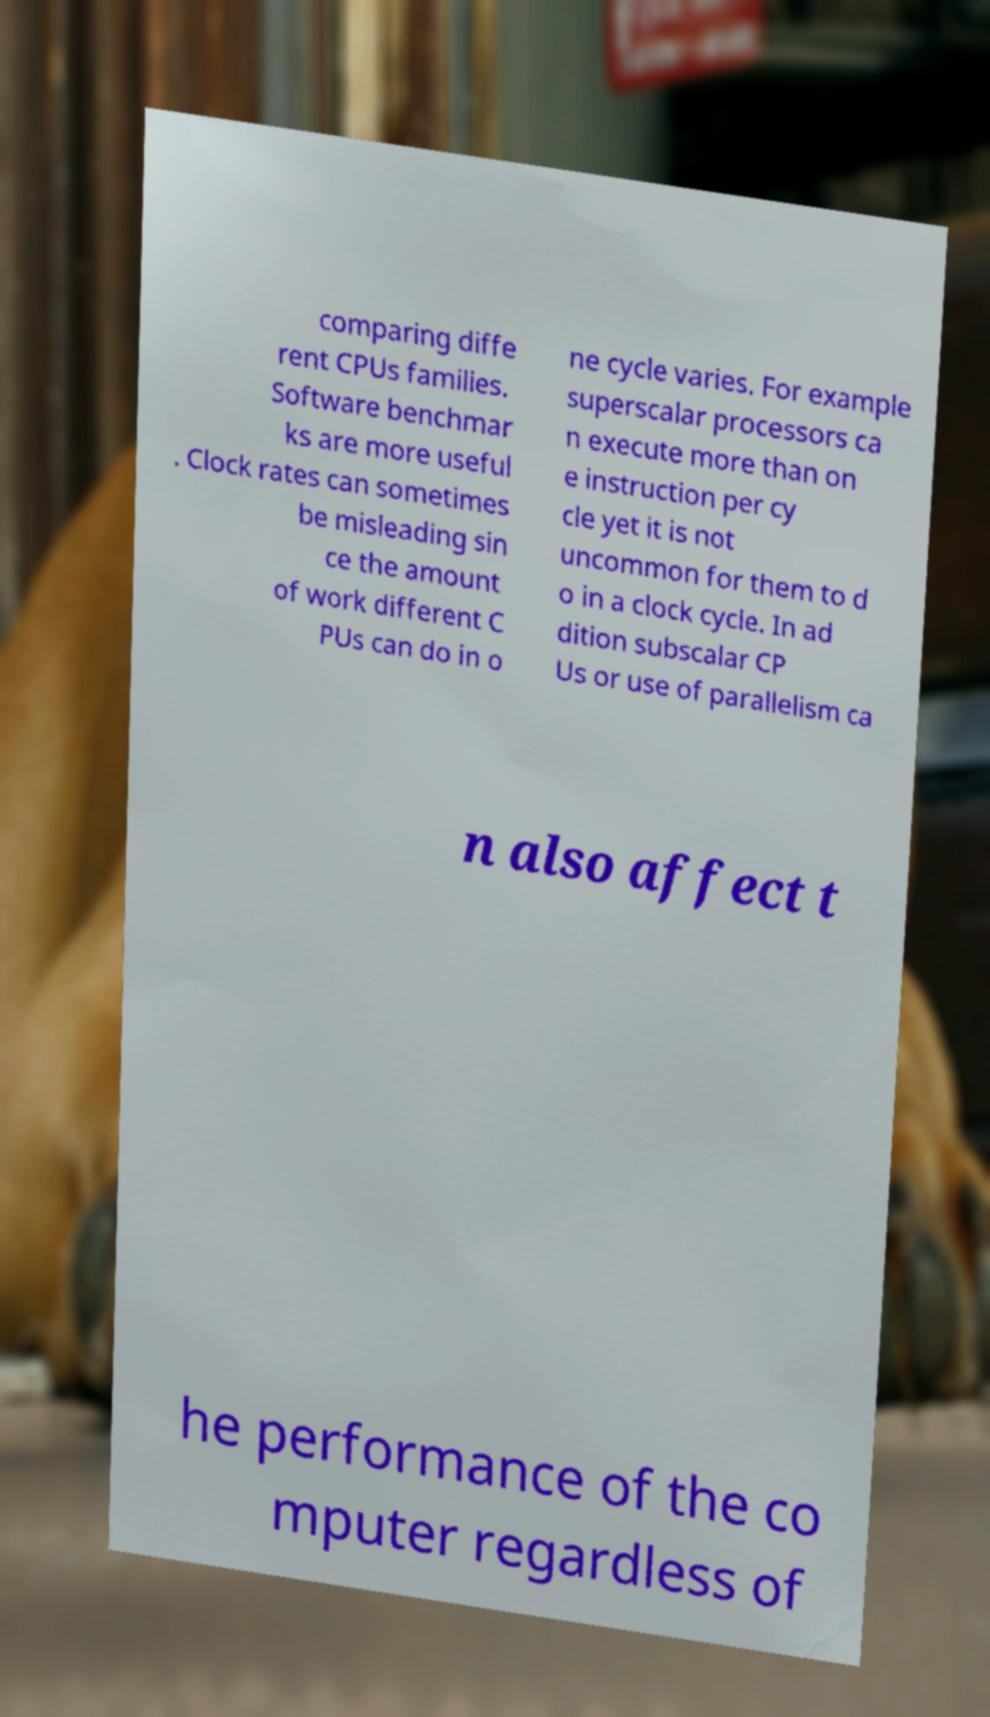What messages or text are displayed in this image? I need them in a readable, typed format. comparing diffe rent CPUs families. Software benchmar ks are more useful . Clock rates can sometimes be misleading sin ce the amount of work different C PUs can do in o ne cycle varies. For example superscalar processors ca n execute more than on e instruction per cy cle yet it is not uncommon for them to d o in a clock cycle. In ad dition subscalar CP Us or use of parallelism ca n also affect t he performance of the co mputer regardless of 